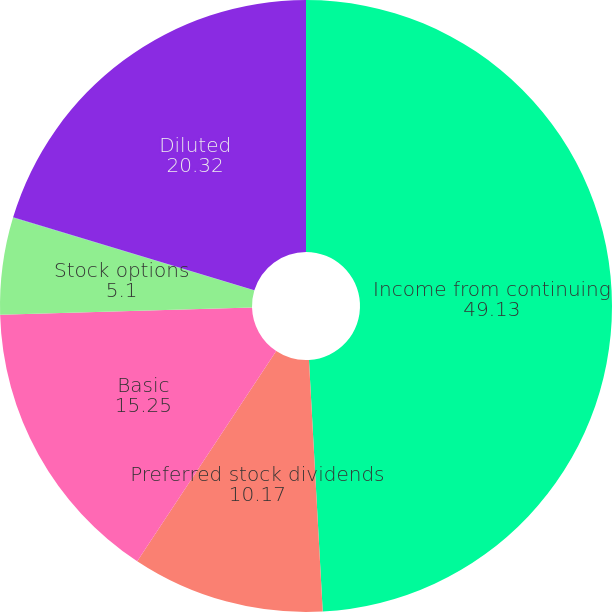Convert chart. <chart><loc_0><loc_0><loc_500><loc_500><pie_chart><fcel>Income from continuing<fcel>Preferred stock dividends<fcel>Basic<fcel>Stock options<fcel>Restricted stock units<fcel>Diluted<nl><fcel>49.13%<fcel>10.17%<fcel>15.25%<fcel>5.1%<fcel>0.03%<fcel>20.32%<nl></chart> 